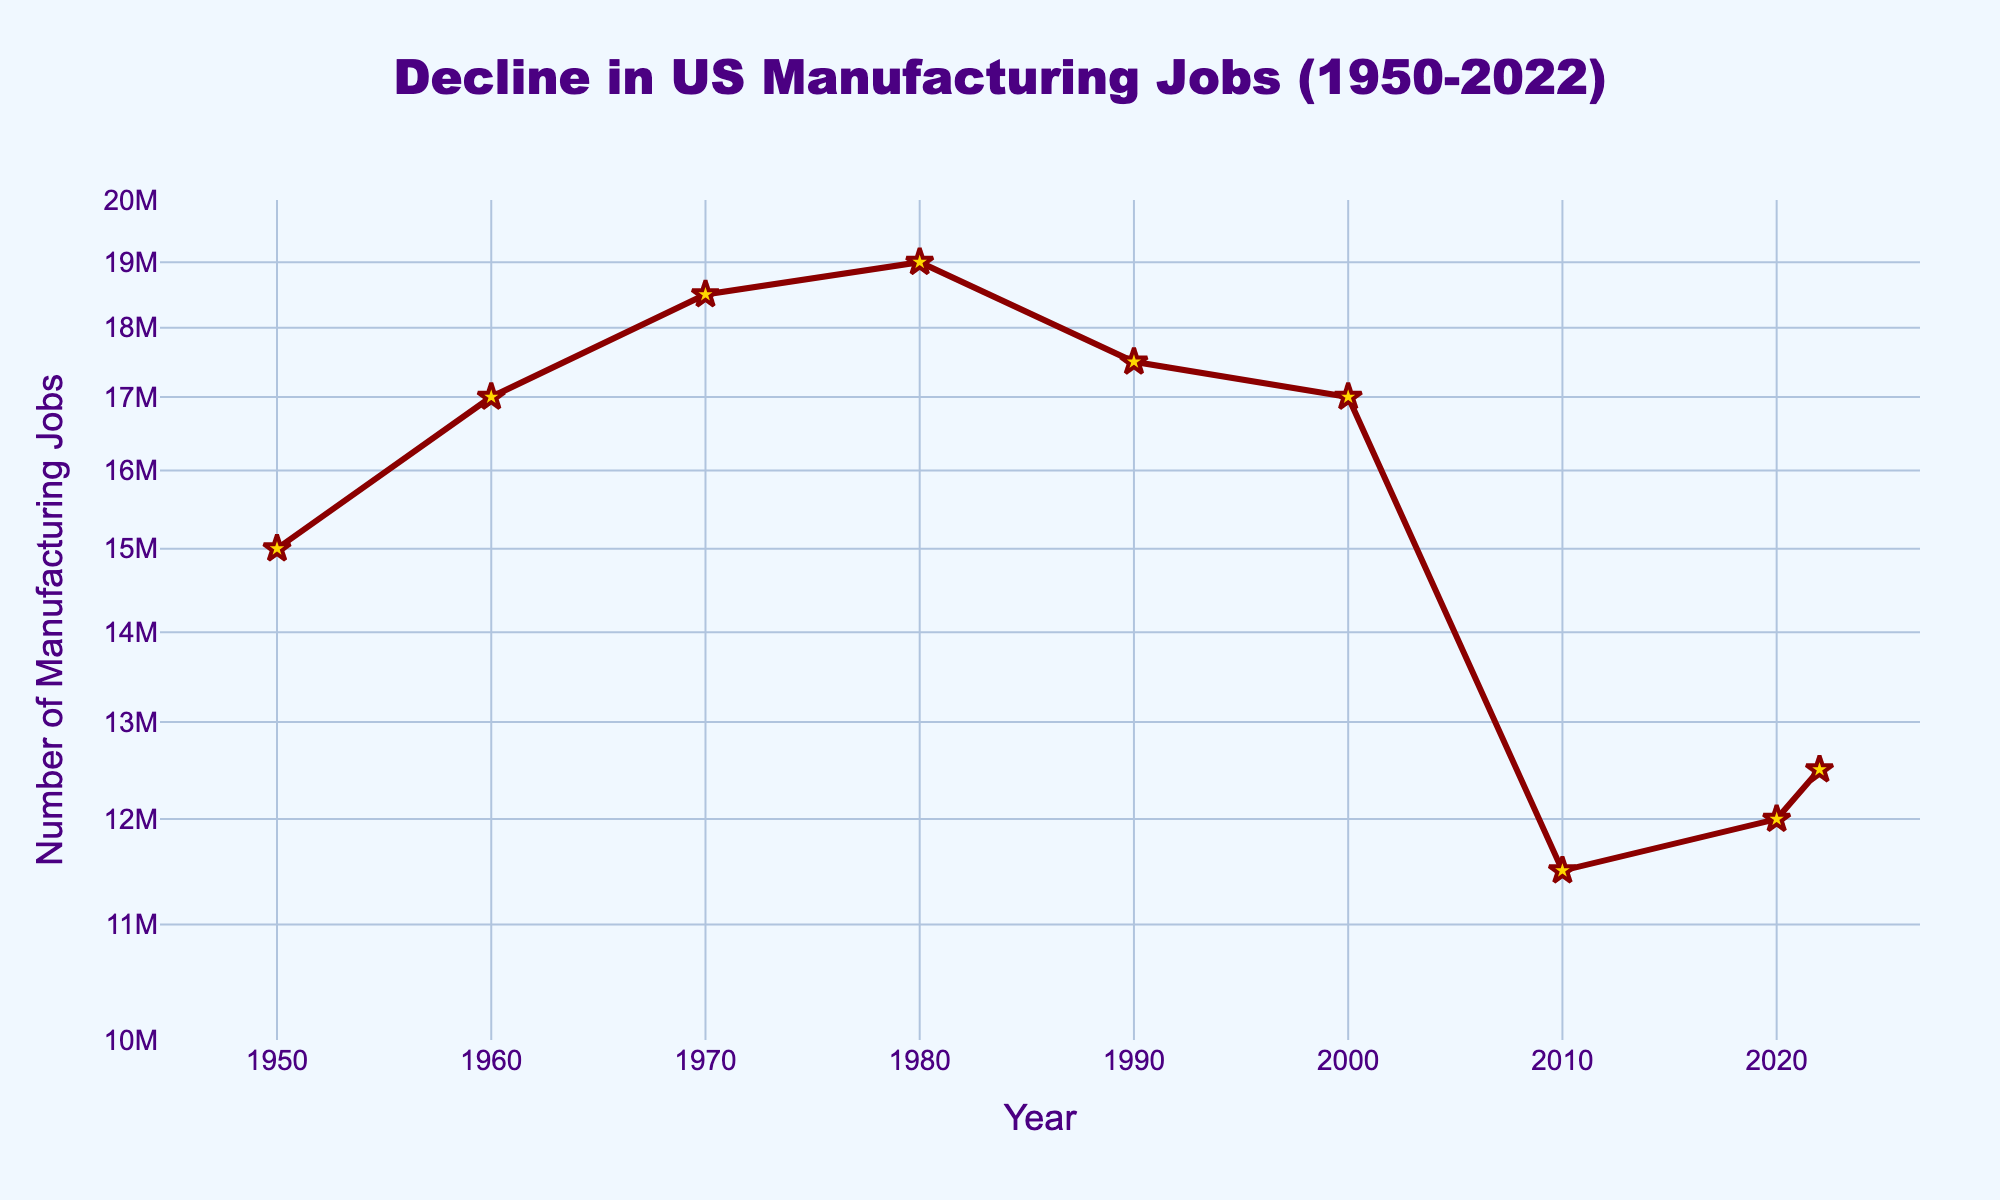When does the figure show the highest number of manufacturing jobs? The figure displays markers indicating yearly manufacturing jobs. The highest marker is at the year 1980, which shows 19,000,000 manufacturing jobs.
Answer: 1980 What is the general trend shown in the plot from 1950 to 2022? Observing the line connecting each year's data points from 1950 to 2022, there's an overall decrease in the number of manufacturing jobs, despite some fluctuations.
Answer: Decline How many years have manufacturing jobs dropped between 1980 and 2010? Between 1980 (19,000,000 jobs) and 2010 (11,500,000 jobs), the number of jobs has dropped in those 30 years.
Answer: 30 years What's the approximate percentage decrease in manufacturing jobs from 1980 to 2010? The number of jobs decreased from 19,000,000 to 11,500,000. The decrease is 19,000,000 - 11,500,000 = 7,500,000. The percentage decrease is (7,500,000 / 19,000,000) * 100 ≈ 39.47%.
Answer: 39.47% Which period is labeled as the "Industrial Revolution Era"? The annotation "Industrial Revolution Era" is placed near the data point for the year 1950 on the plot, indicating this period.
Answer: 1950 By how much did the number of manufacturing jobs increase from 2010 to 2022? From the figure, jobs increased from 11,500,000 in 2010 to 12,500,000 in 2022. The increase is 12,500,000 - 11,500,000 = 1,000,000.
Answer: 1,000,000 Which year shows the most significant drop in manufacturing jobs compared to its previous decade? Comparing the changes, the most significant drop is from 2000 (17,000,000) to 2010 (11,500,000), a decrease of 5,500,000.
Answer: 2010 What is the main color used for the line representing manufacturing jobs on the plot? The line color representing manufacturing jobs is a deep red.
Answer: Deep red How many times does the data set show an increase in the number of manufacturing jobs? The increases occur from 1950 to 1960, 1960 to 1970, 1970 to 1980, and 2010 to 2020; totaling four increases.
Answer: Four times 